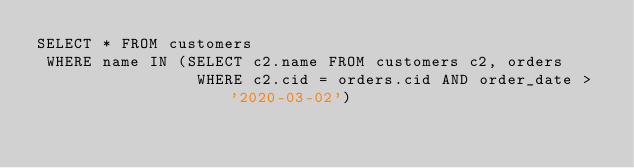<code> <loc_0><loc_0><loc_500><loc_500><_SQL_>SELECT * FROM customers
 WHERE name IN (SELECT c2.name FROM customers c2, orders
                 WHERE c2.cid = orders.cid AND order_date > '2020-03-02')</code> 